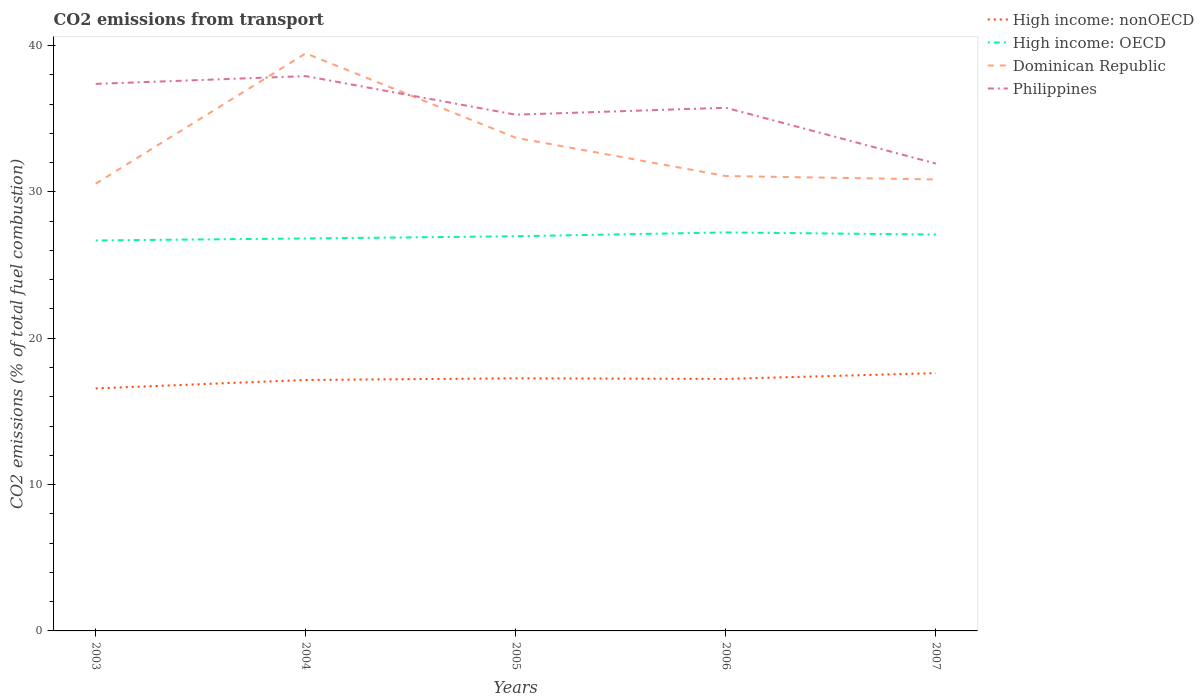How many different coloured lines are there?
Provide a short and direct response. 4. Does the line corresponding to Philippines intersect with the line corresponding to High income: nonOECD?
Your answer should be very brief. No. Across all years, what is the maximum total CO2 emitted in Dominican Republic?
Make the answer very short. 30.56. In which year was the total CO2 emitted in Philippines maximum?
Ensure brevity in your answer.  2007. What is the total total CO2 emitted in Dominican Republic in the graph?
Offer a very short reply. 2.62. What is the difference between the highest and the second highest total CO2 emitted in Dominican Republic?
Ensure brevity in your answer.  8.91. What is the difference between the highest and the lowest total CO2 emitted in High income: OECD?
Offer a terse response. 3. Is the total CO2 emitted in High income: nonOECD strictly greater than the total CO2 emitted in High income: OECD over the years?
Your answer should be compact. Yes. How many years are there in the graph?
Your answer should be compact. 5. Where does the legend appear in the graph?
Ensure brevity in your answer.  Top right. What is the title of the graph?
Provide a short and direct response. CO2 emissions from transport. What is the label or title of the X-axis?
Make the answer very short. Years. What is the label or title of the Y-axis?
Keep it short and to the point. CO2 emissions (% of total fuel combustion). What is the CO2 emissions (% of total fuel combustion) of High income: nonOECD in 2003?
Your answer should be very brief. 16.57. What is the CO2 emissions (% of total fuel combustion) in High income: OECD in 2003?
Make the answer very short. 26.68. What is the CO2 emissions (% of total fuel combustion) in Dominican Republic in 2003?
Your answer should be very brief. 30.56. What is the CO2 emissions (% of total fuel combustion) of Philippines in 2003?
Make the answer very short. 37.38. What is the CO2 emissions (% of total fuel combustion) in High income: nonOECD in 2004?
Offer a very short reply. 17.15. What is the CO2 emissions (% of total fuel combustion) of High income: OECD in 2004?
Make the answer very short. 26.82. What is the CO2 emissions (% of total fuel combustion) in Dominican Republic in 2004?
Ensure brevity in your answer.  39.47. What is the CO2 emissions (% of total fuel combustion) in Philippines in 2004?
Your answer should be compact. 37.91. What is the CO2 emissions (% of total fuel combustion) in High income: nonOECD in 2005?
Your response must be concise. 17.26. What is the CO2 emissions (% of total fuel combustion) of High income: OECD in 2005?
Your answer should be compact. 26.97. What is the CO2 emissions (% of total fuel combustion) in Dominican Republic in 2005?
Keep it short and to the point. 33.7. What is the CO2 emissions (% of total fuel combustion) in Philippines in 2005?
Offer a terse response. 35.27. What is the CO2 emissions (% of total fuel combustion) of High income: nonOECD in 2006?
Your answer should be compact. 17.22. What is the CO2 emissions (% of total fuel combustion) in High income: OECD in 2006?
Offer a very short reply. 27.23. What is the CO2 emissions (% of total fuel combustion) of Dominican Republic in 2006?
Give a very brief answer. 31.08. What is the CO2 emissions (% of total fuel combustion) in Philippines in 2006?
Offer a very short reply. 35.75. What is the CO2 emissions (% of total fuel combustion) of High income: nonOECD in 2007?
Offer a very short reply. 17.62. What is the CO2 emissions (% of total fuel combustion) of High income: OECD in 2007?
Ensure brevity in your answer.  27.08. What is the CO2 emissions (% of total fuel combustion) of Dominican Republic in 2007?
Provide a short and direct response. 30.85. What is the CO2 emissions (% of total fuel combustion) in Philippines in 2007?
Provide a short and direct response. 31.93. Across all years, what is the maximum CO2 emissions (% of total fuel combustion) of High income: nonOECD?
Offer a very short reply. 17.62. Across all years, what is the maximum CO2 emissions (% of total fuel combustion) in High income: OECD?
Offer a terse response. 27.23. Across all years, what is the maximum CO2 emissions (% of total fuel combustion) of Dominican Republic?
Give a very brief answer. 39.47. Across all years, what is the maximum CO2 emissions (% of total fuel combustion) in Philippines?
Give a very brief answer. 37.91. Across all years, what is the minimum CO2 emissions (% of total fuel combustion) in High income: nonOECD?
Offer a terse response. 16.57. Across all years, what is the minimum CO2 emissions (% of total fuel combustion) of High income: OECD?
Give a very brief answer. 26.68. Across all years, what is the minimum CO2 emissions (% of total fuel combustion) in Dominican Republic?
Make the answer very short. 30.56. Across all years, what is the minimum CO2 emissions (% of total fuel combustion) of Philippines?
Ensure brevity in your answer.  31.93. What is the total CO2 emissions (% of total fuel combustion) in High income: nonOECD in the graph?
Your answer should be very brief. 85.81. What is the total CO2 emissions (% of total fuel combustion) in High income: OECD in the graph?
Your answer should be compact. 134.78. What is the total CO2 emissions (% of total fuel combustion) of Dominican Republic in the graph?
Offer a terse response. 165.66. What is the total CO2 emissions (% of total fuel combustion) of Philippines in the graph?
Keep it short and to the point. 178.25. What is the difference between the CO2 emissions (% of total fuel combustion) in High income: nonOECD in 2003 and that in 2004?
Keep it short and to the point. -0.58. What is the difference between the CO2 emissions (% of total fuel combustion) in High income: OECD in 2003 and that in 2004?
Offer a terse response. -0.14. What is the difference between the CO2 emissions (% of total fuel combustion) in Dominican Republic in 2003 and that in 2004?
Your answer should be compact. -8.91. What is the difference between the CO2 emissions (% of total fuel combustion) in Philippines in 2003 and that in 2004?
Your answer should be compact. -0.53. What is the difference between the CO2 emissions (% of total fuel combustion) in High income: nonOECD in 2003 and that in 2005?
Keep it short and to the point. -0.69. What is the difference between the CO2 emissions (% of total fuel combustion) of High income: OECD in 2003 and that in 2005?
Offer a very short reply. -0.29. What is the difference between the CO2 emissions (% of total fuel combustion) of Dominican Republic in 2003 and that in 2005?
Offer a terse response. -3.14. What is the difference between the CO2 emissions (% of total fuel combustion) of Philippines in 2003 and that in 2005?
Provide a succinct answer. 2.1. What is the difference between the CO2 emissions (% of total fuel combustion) of High income: nonOECD in 2003 and that in 2006?
Make the answer very short. -0.65. What is the difference between the CO2 emissions (% of total fuel combustion) of High income: OECD in 2003 and that in 2006?
Provide a short and direct response. -0.55. What is the difference between the CO2 emissions (% of total fuel combustion) of Dominican Republic in 2003 and that in 2006?
Ensure brevity in your answer.  -0.52. What is the difference between the CO2 emissions (% of total fuel combustion) of Philippines in 2003 and that in 2006?
Provide a succinct answer. 1.63. What is the difference between the CO2 emissions (% of total fuel combustion) of High income: nonOECD in 2003 and that in 2007?
Keep it short and to the point. -1.05. What is the difference between the CO2 emissions (% of total fuel combustion) in High income: OECD in 2003 and that in 2007?
Provide a succinct answer. -0.4. What is the difference between the CO2 emissions (% of total fuel combustion) in Dominican Republic in 2003 and that in 2007?
Provide a short and direct response. -0.29. What is the difference between the CO2 emissions (% of total fuel combustion) in Philippines in 2003 and that in 2007?
Keep it short and to the point. 5.45. What is the difference between the CO2 emissions (% of total fuel combustion) of High income: nonOECD in 2004 and that in 2005?
Offer a very short reply. -0.11. What is the difference between the CO2 emissions (% of total fuel combustion) in High income: OECD in 2004 and that in 2005?
Your response must be concise. -0.15. What is the difference between the CO2 emissions (% of total fuel combustion) in Dominican Republic in 2004 and that in 2005?
Your answer should be compact. 5.77. What is the difference between the CO2 emissions (% of total fuel combustion) of Philippines in 2004 and that in 2005?
Your answer should be compact. 2.64. What is the difference between the CO2 emissions (% of total fuel combustion) in High income: nonOECD in 2004 and that in 2006?
Offer a very short reply. -0.07. What is the difference between the CO2 emissions (% of total fuel combustion) in High income: OECD in 2004 and that in 2006?
Offer a very short reply. -0.41. What is the difference between the CO2 emissions (% of total fuel combustion) of Dominican Republic in 2004 and that in 2006?
Ensure brevity in your answer.  8.38. What is the difference between the CO2 emissions (% of total fuel combustion) of Philippines in 2004 and that in 2006?
Your answer should be compact. 2.16. What is the difference between the CO2 emissions (% of total fuel combustion) of High income: nonOECD in 2004 and that in 2007?
Offer a terse response. -0.47. What is the difference between the CO2 emissions (% of total fuel combustion) in High income: OECD in 2004 and that in 2007?
Offer a very short reply. -0.27. What is the difference between the CO2 emissions (% of total fuel combustion) of Dominican Republic in 2004 and that in 2007?
Offer a very short reply. 8.62. What is the difference between the CO2 emissions (% of total fuel combustion) in Philippines in 2004 and that in 2007?
Provide a succinct answer. 5.98. What is the difference between the CO2 emissions (% of total fuel combustion) in High income: nonOECD in 2005 and that in 2006?
Provide a succinct answer. 0.04. What is the difference between the CO2 emissions (% of total fuel combustion) in High income: OECD in 2005 and that in 2006?
Offer a terse response. -0.26. What is the difference between the CO2 emissions (% of total fuel combustion) in Dominican Republic in 2005 and that in 2006?
Offer a terse response. 2.62. What is the difference between the CO2 emissions (% of total fuel combustion) in Philippines in 2005 and that in 2006?
Keep it short and to the point. -0.48. What is the difference between the CO2 emissions (% of total fuel combustion) of High income: nonOECD in 2005 and that in 2007?
Offer a terse response. -0.36. What is the difference between the CO2 emissions (% of total fuel combustion) of High income: OECD in 2005 and that in 2007?
Your answer should be very brief. -0.12. What is the difference between the CO2 emissions (% of total fuel combustion) in Dominican Republic in 2005 and that in 2007?
Your answer should be very brief. 2.85. What is the difference between the CO2 emissions (% of total fuel combustion) of Philippines in 2005 and that in 2007?
Provide a short and direct response. 3.34. What is the difference between the CO2 emissions (% of total fuel combustion) in High income: nonOECD in 2006 and that in 2007?
Offer a very short reply. -0.4. What is the difference between the CO2 emissions (% of total fuel combustion) of High income: OECD in 2006 and that in 2007?
Your response must be concise. 0.15. What is the difference between the CO2 emissions (% of total fuel combustion) in Dominican Republic in 2006 and that in 2007?
Your response must be concise. 0.23. What is the difference between the CO2 emissions (% of total fuel combustion) in Philippines in 2006 and that in 2007?
Provide a succinct answer. 3.82. What is the difference between the CO2 emissions (% of total fuel combustion) of High income: nonOECD in 2003 and the CO2 emissions (% of total fuel combustion) of High income: OECD in 2004?
Give a very brief answer. -10.25. What is the difference between the CO2 emissions (% of total fuel combustion) in High income: nonOECD in 2003 and the CO2 emissions (% of total fuel combustion) in Dominican Republic in 2004?
Keep it short and to the point. -22.9. What is the difference between the CO2 emissions (% of total fuel combustion) in High income: nonOECD in 2003 and the CO2 emissions (% of total fuel combustion) in Philippines in 2004?
Give a very brief answer. -21.34. What is the difference between the CO2 emissions (% of total fuel combustion) of High income: OECD in 2003 and the CO2 emissions (% of total fuel combustion) of Dominican Republic in 2004?
Your answer should be compact. -12.79. What is the difference between the CO2 emissions (% of total fuel combustion) of High income: OECD in 2003 and the CO2 emissions (% of total fuel combustion) of Philippines in 2004?
Ensure brevity in your answer.  -11.23. What is the difference between the CO2 emissions (% of total fuel combustion) of Dominican Republic in 2003 and the CO2 emissions (% of total fuel combustion) of Philippines in 2004?
Give a very brief answer. -7.35. What is the difference between the CO2 emissions (% of total fuel combustion) of High income: nonOECD in 2003 and the CO2 emissions (% of total fuel combustion) of High income: OECD in 2005?
Provide a short and direct response. -10.4. What is the difference between the CO2 emissions (% of total fuel combustion) of High income: nonOECD in 2003 and the CO2 emissions (% of total fuel combustion) of Dominican Republic in 2005?
Keep it short and to the point. -17.13. What is the difference between the CO2 emissions (% of total fuel combustion) in High income: nonOECD in 2003 and the CO2 emissions (% of total fuel combustion) in Philippines in 2005?
Your response must be concise. -18.7. What is the difference between the CO2 emissions (% of total fuel combustion) of High income: OECD in 2003 and the CO2 emissions (% of total fuel combustion) of Dominican Republic in 2005?
Give a very brief answer. -7.02. What is the difference between the CO2 emissions (% of total fuel combustion) of High income: OECD in 2003 and the CO2 emissions (% of total fuel combustion) of Philippines in 2005?
Offer a terse response. -8.59. What is the difference between the CO2 emissions (% of total fuel combustion) of Dominican Republic in 2003 and the CO2 emissions (% of total fuel combustion) of Philippines in 2005?
Give a very brief answer. -4.72. What is the difference between the CO2 emissions (% of total fuel combustion) of High income: nonOECD in 2003 and the CO2 emissions (% of total fuel combustion) of High income: OECD in 2006?
Give a very brief answer. -10.66. What is the difference between the CO2 emissions (% of total fuel combustion) of High income: nonOECD in 2003 and the CO2 emissions (% of total fuel combustion) of Dominican Republic in 2006?
Make the answer very short. -14.51. What is the difference between the CO2 emissions (% of total fuel combustion) in High income: nonOECD in 2003 and the CO2 emissions (% of total fuel combustion) in Philippines in 2006?
Provide a succinct answer. -19.18. What is the difference between the CO2 emissions (% of total fuel combustion) in High income: OECD in 2003 and the CO2 emissions (% of total fuel combustion) in Dominican Republic in 2006?
Your answer should be compact. -4.4. What is the difference between the CO2 emissions (% of total fuel combustion) of High income: OECD in 2003 and the CO2 emissions (% of total fuel combustion) of Philippines in 2006?
Offer a very short reply. -9.07. What is the difference between the CO2 emissions (% of total fuel combustion) of Dominican Republic in 2003 and the CO2 emissions (% of total fuel combustion) of Philippines in 2006?
Ensure brevity in your answer.  -5.19. What is the difference between the CO2 emissions (% of total fuel combustion) in High income: nonOECD in 2003 and the CO2 emissions (% of total fuel combustion) in High income: OECD in 2007?
Provide a succinct answer. -10.51. What is the difference between the CO2 emissions (% of total fuel combustion) of High income: nonOECD in 2003 and the CO2 emissions (% of total fuel combustion) of Dominican Republic in 2007?
Your answer should be very brief. -14.28. What is the difference between the CO2 emissions (% of total fuel combustion) of High income: nonOECD in 2003 and the CO2 emissions (% of total fuel combustion) of Philippines in 2007?
Provide a succinct answer. -15.36. What is the difference between the CO2 emissions (% of total fuel combustion) of High income: OECD in 2003 and the CO2 emissions (% of total fuel combustion) of Dominican Republic in 2007?
Your response must be concise. -4.17. What is the difference between the CO2 emissions (% of total fuel combustion) in High income: OECD in 2003 and the CO2 emissions (% of total fuel combustion) in Philippines in 2007?
Make the answer very short. -5.25. What is the difference between the CO2 emissions (% of total fuel combustion) in Dominican Republic in 2003 and the CO2 emissions (% of total fuel combustion) in Philippines in 2007?
Make the answer very short. -1.37. What is the difference between the CO2 emissions (% of total fuel combustion) of High income: nonOECD in 2004 and the CO2 emissions (% of total fuel combustion) of High income: OECD in 2005?
Provide a succinct answer. -9.82. What is the difference between the CO2 emissions (% of total fuel combustion) of High income: nonOECD in 2004 and the CO2 emissions (% of total fuel combustion) of Dominican Republic in 2005?
Your answer should be compact. -16.55. What is the difference between the CO2 emissions (% of total fuel combustion) of High income: nonOECD in 2004 and the CO2 emissions (% of total fuel combustion) of Philippines in 2005?
Your response must be concise. -18.13. What is the difference between the CO2 emissions (% of total fuel combustion) of High income: OECD in 2004 and the CO2 emissions (% of total fuel combustion) of Dominican Republic in 2005?
Make the answer very short. -6.88. What is the difference between the CO2 emissions (% of total fuel combustion) of High income: OECD in 2004 and the CO2 emissions (% of total fuel combustion) of Philippines in 2005?
Ensure brevity in your answer.  -8.46. What is the difference between the CO2 emissions (% of total fuel combustion) of Dominican Republic in 2004 and the CO2 emissions (% of total fuel combustion) of Philippines in 2005?
Offer a very short reply. 4.19. What is the difference between the CO2 emissions (% of total fuel combustion) of High income: nonOECD in 2004 and the CO2 emissions (% of total fuel combustion) of High income: OECD in 2006?
Give a very brief answer. -10.08. What is the difference between the CO2 emissions (% of total fuel combustion) of High income: nonOECD in 2004 and the CO2 emissions (% of total fuel combustion) of Dominican Republic in 2006?
Offer a terse response. -13.94. What is the difference between the CO2 emissions (% of total fuel combustion) of High income: nonOECD in 2004 and the CO2 emissions (% of total fuel combustion) of Philippines in 2006?
Your answer should be compact. -18.6. What is the difference between the CO2 emissions (% of total fuel combustion) of High income: OECD in 2004 and the CO2 emissions (% of total fuel combustion) of Dominican Republic in 2006?
Offer a terse response. -4.27. What is the difference between the CO2 emissions (% of total fuel combustion) of High income: OECD in 2004 and the CO2 emissions (% of total fuel combustion) of Philippines in 2006?
Your answer should be compact. -8.93. What is the difference between the CO2 emissions (% of total fuel combustion) in Dominican Republic in 2004 and the CO2 emissions (% of total fuel combustion) in Philippines in 2006?
Provide a short and direct response. 3.72. What is the difference between the CO2 emissions (% of total fuel combustion) in High income: nonOECD in 2004 and the CO2 emissions (% of total fuel combustion) in High income: OECD in 2007?
Provide a short and direct response. -9.94. What is the difference between the CO2 emissions (% of total fuel combustion) in High income: nonOECD in 2004 and the CO2 emissions (% of total fuel combustion) in Dominican Republic in 2007?
Ensure brevity in your answer.  -13.7. What is the difference between the CO2 emissions (% of total fuel combustion) in High income: nonOECD in 2004 and the CO2 emissions (% of total fuel combustion) in Philippines in 2007?
Keep it short and to the point. -14.79. What is the difference between the CO2 emissions (% of total fuel combustion) of High income: OECD in 2004 and the CO2 emissions (% of total fuel combustion) of Dominican Republic in 2007?
Provide a succinct answer. -4.03. What is the difference between the CO2 emissions (% of total fuel combustion) in High income: OECD in 2004 and the CO2 emissions (% of total fuel combustion) in Philippines in 2007?
Your response must be concise. -5.12. What is the difference between the CO2 emissions (% of total fuel combustion) in Dominican Republic in 2004 and the CO2 emissions (% of total fuel combustion) in Philippines in 2007?
Your response must be concise. 7.53. What is the difference between the CO2 emissions (% of total fuel combustion) in High income: nonOECD in 2005 and the CO2 emissions (% of total fuel combustion) in High income: OECD in 2006?
Keep it short and to the point. -9.97. What is the difference between the CO2 emissions (% of total fuel combustion) in High income: nonOECD in 2005 and the CO2 emissions (% of total fuel combustion) in Dominican Republic in 2006?
Your response must be concise. -13.82. What is the difference between the CO2 emissions (% of total fuel combustion) of High income: nonOECD in 2005 and the CO2 emissions (% of total fuel combustion) of Philippines in 2006?
Keep it short and to the point. -18.49. What is the difference between the CO2 emissions (% of total fuel combustion) of High income: OECD in 2005 and the CO2 emissions (% of total fuel combustion) of Dominican Republic in 2006?
Your answer should be compact. -4.12. What is the difference between the CO2 emissions (% of total fuel combustion) of High income: OECD in 2005 and the CO2 emissions (% of total fuel combustion) of Philippines in 2006?
Your answer should be compact. -8.78. What is the difference between the CO2 emissions (% of total fuel combustion) in Dominican Republic in 2005 and the CO2 emissions (% of total fuel combustion) in Philippines in 2006?
Ensure brevity in your answer.  -2.05. What is the difference between the CO2 emissions (% of total fuel combustion) of High income: nonOECD in 2005 and the CO2 emissions (% of total fuel combustion) of High income: OECD in 2007?
Ensure brevity in your answer.  -9.82. What is the difference between the CO2 emissions (% of total fuel combustion) in High income: nonOECD in 2005 and the CO2 emissions (% of total fuel combustion) in Dominican Republic in 2007?
Your answer should be very brief. -13.59. What is the difference between the CO2 emissions (% of total fuel combustion) in High income: nonOECD in 2005 and the CO2 emissions (% of total fuel combustion) in Philippines in 2007?
Ensure brevity in your answer.  -14.67. What is the difference between the CO2 emissions (% of total fuel combustion) in High income: OECD in 2005 and the CO2 emissions (% of total fuel combustion) in Dominican Republic in 2007?
Keep it short and to the point. -3.88. What is the difference between the CO2 emissions (% of total fuel combustion) of High income: OECD in 2005 and the CO2 emissions (% of total fuel combustion) of Philippines in 2007?
Provide a short and direct response. -4.97. What is the difference between the CO2 emissions (% of total fuel combustion) of Dominican Republic in 2005 and the CO2 emissions (% of total fuel combustion) of Philippines in 2007?
Your response must be concise. 1.77. What is the difference between the CO2 emissions (% of total fuel combustion) in High income: nonOECD in 2006 and the CO2 emissions (% of total fuel combustion) in High income: OECD in 2007?
Keep it short and to the point. -9.86. What is the difference between the CO2 emissions (% of total fuel combustion) of High income: nonOECD in 2006 and the CO2 emissions (% of total fuel combustion) of Dominican Republic in 2007?
Your answer should be very brief. -13.63. What is the difference between the CO2 emissions (% of total fuel combustion) in High income: nonOECD in 2006 and the CO2 emissions (% of total fuel combustion) in Philippines in 2007?
Give a very brief answer. -14.71. What is the difference between the CO2 emissions (% of total fuel combustion) in High income: OECD in 2006 and the CO2 emissions (% of total fuel combustion) in Dominican Republic in 2007?
Your response must be concise. -3.62. What is the difference between the CO2 emissions (% of total fuel combustion) of High income: OECD in 2006 and the CO2 emissions (% of total fuel combustion) of Philippines in 2007?
Give a very brief answer. -4.7. What is the difference between the CO2 emissions (% of total fuel combustion) of Dominican Republic in 2006 and the CO2 emissions (% of total fuel combustion) of Philippines in 2007?
Your answer should be compact. -0.85. What is the average CO2 emissions (% of total fuel combustion) of High income: nonOECD per year?
Give a very brief answer. 17.16. What is the average CO2 emissions (% of total fuel combustion) of High income: OECD per year?
Offer a terse response. 26.96. What is the average CO2 emissions (% of total fuel combustion) of Dominican Republic per year?
Offer a terse response. 33.13. What is the average CO2 emissions (% of total fuel combustion) in Philippines per year?
Offer a terse response. 35.65. In the year 2003, what is the difference between the CO2 emissions (% of total fuel combustion) of High income: nonOECD and CO2 emissions (% of total fuel combustion) of High income: OECD?
Provide a short and direct response. -10.11. In the year 2003, what is the difference between the CO2 emissions (% of total fuel combustion) in High income: nonOECD and CO2 emissions (% of total fuel combustion) in Dominican Republic?
Keep it short and to the point. -13.99. In the year 2003, what is the difference between the CO2 emissions (% of total fuel combustion) of High income: nonOECD and CO2 emissions (% of total fuel combustion) of Philippines?
Provide a succinct answer. -20.81. In the year 2003, what is the difference between the CO2 emissions (% of total fuel combustion) of High income: OECD and CO2 emissions (% of total fuel combustion) of Dominican Republic?
Provide a short and direct response. -3.88. In the year 2003, what is the difference between the CO2 emissions (% of total fuel combustion) of High income: OECD and CO2 emissions (% of total fuel combustion) of Philippines?
Your answer should be compact. -10.7. In the year 2003, what is the difference between the CO2 emissions (% of total fuel combustion) in Dominican Republic and CO2 emissions (% of total fuel combustion) in Philippines?
Make the answer very short. -6.82. In the year 2004, what is the difference between the CO2 emissions (% of total fuel combustion) in High income: nonOECD and CO2 emissions (% of total fuel combustion) in High income: OECD?
Offer a very short reply. -9.67. In the year 2004, what is the difference between the CO2 emissions (% of total fuel combustion) in High income: nonOECD and CO2 emissions (% of total fuel combustion) in Dominican Republic?
Provide a short and direct response. -22.32. In the year 2004, what is the difference between the CO2 emissions (% of total fuel combustion) in High income: nonOECD and CO2 emissions (% of total fuel combustion) in Philippines?
Ensure brevity in your answer.  -20.76. In the year 2004, what is the difference between the CO2 emissions (% of total fuel combustion) in High income: OECD and CO2 emissions (% of total fuel combustion) in Dominican Republic?
Make the answer very short. -12.65. In the year 2004, what is the difference between the CO2 emissions (% of total fuel combustion) of High income: OECD and CO2 emissions (% of total fuel combustion) of Philippines?
Keep it short and to the point. -11.09. In the year 2004, what is the difference between the CO2 emissions (% of total fuel combustion) of Dominican Republic and CO2 emissions (% of total fuel combustion) of Philippines?
Keep it short and to the point. 1.56. In the year 2005, what is the difference between the CO2 emissions (% of total fuel combustion) of High income: nonOECD and CO2 emissions (% of total fuel combustion) of High income: OECD?
Your answer should be compact. -9.71. In the year 2005, what is the difference between the CO2 emissions (% of total fuel combustion) in High income: nonOECD and CO2 emissions (% of total fuel combustion) in Dominican Republic?
Provide a short and direct response. -16.44. In the year 2005, what is the difference between the CO2 emissions (% of total fuel combustion) of High income: nonOECD and CO2 emissions (% of total fuel combustion) of Philippines?
Your response must be concise. -18.01. In the year 2005, what is the difference between the CO2 emissions (% of total fuel combustion) of High income: OECD and CO2 emissions (% of total fuel combustion) of Dominican Republic?
Provide a short and direct response. -6.73. In the year 2005, what is the difference between the CO2 emissions (% of total fuel combustion) of High income: OECD and CO2 emissions (% of total fuel combustion) of Philippines?
Ensure brevity in your answer.  -8.31. In the year 2005, what is the difference between the CO2 emissions (% of total fuel combustion) in Dominican Republic and CO2 emissions (% of total fuel combustion) in Philippines?
Provide a short and direct response. -1.58. In the year 2006, what is the difference between the CO2 emissions (% of total fuel combustion) of High income: nonOECD and CO2 emissions (% of total fuel combustion) of High income: OECD?
Keep it short and to the point. -10.01. In the year 2006, what is the difference between the CO2 emissions (% of total fuel combustion) in High income: nonOECD and CO2 emissions (% of total fuel combustion) in Dominican Republic?
Give a very brief answer. -13.86. In the year 2006, what is the difference between the CO2 emissions (% of total fuel combustion) in High income: nonOECD and CO2 emissions (% of total fuel combustion) in Philippines?
Your answer should be compact. -18.53. In the year 2006, what is the difference between the CO2 emissions (% of total fuel combustion) in High income: OECD and CO2 emissions (% of total fuel combustion) in Dominican Republic?
Your answer should be very brief. -3.85. In the year 2006, what is the difference between the CO2 emissions (% of total fuel combustion) in High income: OECD and CO2 emissions (% of total fuel combustion) in Philippines?
Give a very brief answer. -8.52. In the year 2006, what is the difference between the CO2 emissions (% of total fuel combustion) in Dominican Republic and CO2 emissions (% of total fuel combustion) in Philippines?
Offer a terse response. -4.67. In the year 2007, what is the difference between the CO2 emissions (% of total fuel combustion) of High income: nonOECD and CO2 emissions (% of total fuel combustion) of High income: OECD?
Ensure brevity in your answer.  -9.47. In the year 2007, what is the difference between the CO2 emissions (% of total fuel combustion) in High income: nonOECD and CO2 emissions (% of total fuel combustion) in Dominican Republic?
Give a very brief answer. -13.23. In the year 2007, what is the difference between the CO2 emissions (% of total fuel combustion) in High income: nonOECD and CO2 emissions (% of total fuel combustion) in Philippines?
Offer a terse response. -14.32. In the year 2007, what is the difference between the CO2 emissions (% of total fuel combustion) of High income: OECD and CO2 emissions (% of total fuel combustion) of Dominican Republic?
Your answer should be compact. -3.77. In the year 2007, what is the difference between the CO2 emissions (% of total fuel combustion) in High income: OECD and CO2 emissions (% of total fuel combustion) in Philippines?
Offer a terse response. -4.85. In the year 2007, what is the difference between the CO2 emissions (% of total fuel combustion) of Dominican Republic and CO2 emissions (% of total fuel combustion) of Philippines?
Offer a very short reply. -1.08. What is the ratio of the CO2 emissions (% of total fuel combustion) of High income: nonOECD in 2003 to that in 2004?
Provide a short and direct response. 0.97. What is the ratio of the CO2 emissions (% of total fuel combustion) of Dominican Republic in 2003 to that in 2004?
Your response must be concise. 0.77. What is the ratio of the CO2 emissions (% of total fuel combustion) in Philippines in 2003 to that in 2004?
Your answer should be compact. 0.99. What is the ratio of the CO2 emissions (% of total fuel combustion) in High income: nonOECD in 2003 to that in 2005?
Provide a succinct answer. 0.96. What is the ratio of the CO2 emissions (% of total fuel combustion) of Dominican Republic in 2003 to that in 2005?
Give a very brief answer. 0.91. What is the ratio of the CO2 emissions (% of total fuel combustion) of Philippines in 2003 to that in 2005?
Ensure brevity in your answer.  1.06. What is the ratio of the CO2 emissions (% of total fuel combustion) of High income: nonOECD in 2003 to that in 2006?
Your answer should be very brief. 0.96. What is the ratio of the CO2 emissions (% of total fuel combustion) of High income: OECD in 2003 to that in 2006?
Provide a succinct answer. 0.98. What is the ratio of the CO2 emissions (% of total fuel combustion) of Dominican Republic in 2003 to that in 2006?
Provide a short and direct response. 0.98. What is the ratio of the CO2 emissions (% of total fuel combustion) in Philippines in 2003 to that in 2006?
Ensure brevity in your answer.  1.05. What is the ratio of the CO2 emissions (% of total fuel combustion) in High income: nonOECD in 2003 to that in 2007?
Your answer should be compact. 0.94. What is the ratio of the CO2 emissions (% of total fuel combustion) in High income: OECD in 2003 to that in 2007?
Keep it short and to the point. 0.99. What is the ratio of the CO2 emissions (% of total fuel combustion) in Dominican Republic in 2003 to that in 2007?
Your response must be concise. 0.99. What is the ratio of the CO2 emissions (% of total fuel combustion) of Philippines in 2003 to that in 2007?
Provide a short and direct response. 1.17. What is the ratio of the CO2 emissions (% of total fuel combustion) in High income: nonOECD in 2004 to that in 2005?
Keep it short and to the point. 0.99. What is the ratio of the CO2 emissions (% of total fuel combustion) in High income: OECD in 2004 to that in 2005?
Offer a very short reply. 0.99. What is the ratio of the CO2 emissions (% of total fuel combustion) in Dominican Republic in 2004 to that in 2005?
Ensure brevity in your answer.  1.17. What is the ratio of the CO2 emissions (% of total fuel combustion) of Philippines in 2004 to that in 2005?
Make the answer very short. 1.07. What is the ratio of the CO2 emissions (% of total fuel combustion) in High income: nonOECD in 2004 to that in 2006?
Your response must be concise. 1. What is the ratio of the CO2 emissions (% of total fuel combustion) of High income: OECD in 2004 to that in 2006?
Give a very brief answer. 0.98. What is the ratio of the CO2 emissions (% of total fuel combustion) of Dominican Republic in 2004 to that in 2006?
Make the answer very short. 1.27. What is the ratio of the CO2 emissions (% of total fuel combustion) in Philippines in 2004 to that in 2006?
Your response must be concise. 1.06. What is the ratio of the CO2 emissions (% of total fuel combustion) of High income: nonOECD in 2004 to that in 2007?
Give a very brief answer. 0.97. What is the ratio of the CO2 emissions (% of total fuel combustion) in Dominican Republic in 2004 to that in 2007?
Your response must be concise. 1.28. What is the ratio of the CO2 emissions (% of total fuel combustion) in Philippines in 2004 to that in 2007?
Give a very brief answer. 1.19. What is the ratio of the CO2 emissions (% of total fuel combustion) of High income: nonOECD in 2005 to that in 2006?
Your answer should be very brief. 1. What is the ratio of the CO2 emissions (% of total fuel combustion) of Dominican Republic in 2005 to that in 2006?
Make the answer very short. 1.08. What is the ratio of the CO2 emissions (% of total fuel combustion) in Philippines in 2005 to that in 2006?
Make the answer very short. 0.99. What is the ratio of the CO2 emissions (% of total fuel combustion) of High income: nonOECD in 2005 to that in 2007?
Ensure brevity in your answer.  0.98. What is the ratio of the CO2 emissions (% of total fuel combustion) in Dominican Republic in 2005 to that in 2007?
Provide a succinct answer. 1.09. What is the ratio of the CO2 emissions (% of total fuel combustion) of Philippines in 2005 to that in 2007?
Provide a short and direct response. 1.1. What is the ratio of the CO2 emissions (% of total fuel combustion) of High income: nonOECD in 2006 to that in 2007?
Your response must be concise. 0.98. What is the ratio of the CO2 emissions (% of total fuel combustion) in High income: OECD in 2006 to that in 2007?
Provide a succinct answer. 1.01. What is the ratio of the CO2 emissions (% of total fuel combustion) in Dominican Republic in 2006 to that in 2007?
Keep it short and to the point. 1.01. What is the ratio of the CO2 emissions (% of total fuel combustion) in Philippines in 2006 to that in 2007?
Your answer should be very brief. 1.12. What is the difference between the highest and the second highest CO2 emissions (% of total fuel combustion) in High income: nonOECD?
Ensure brevity in your answer.  0.36. What is the difference between the highest and the second highest CO2 emissions (% of total fuel combustion) in High income: OECD?
Your answer should be very brief. 0.15. What is the difference between the highest and the second highest CO2 emissions (% of total fuel combustion) of Dominican Republic?
Your response must be concise. 5.77. What is the difference between the highest and the second highest CO2 emissions (% of total fuel combustion) in Philippines?
Offer a terse response. 0.53. What is the difference between the highest and the lowest CO2 emissions (% of total fuel combustion) of High income: nonOECD?
Give a very brief answer. 1.05. What is the difference between the highest and the lowest CO2 emissions (% of total fuel combustion) in High income: OECD?
Ensure brevity in your answer.  0.55. What is the difference between the highest and the lowest CO2 emissions (% of total fuel combustion) in Dominican Republic?
Your answer should be compact. 8.91. What is the difference between the highest and the lowest CO2 emissions (% of total fuel combustion) in Philippines?
Provide a short and direct response. 5.98. 